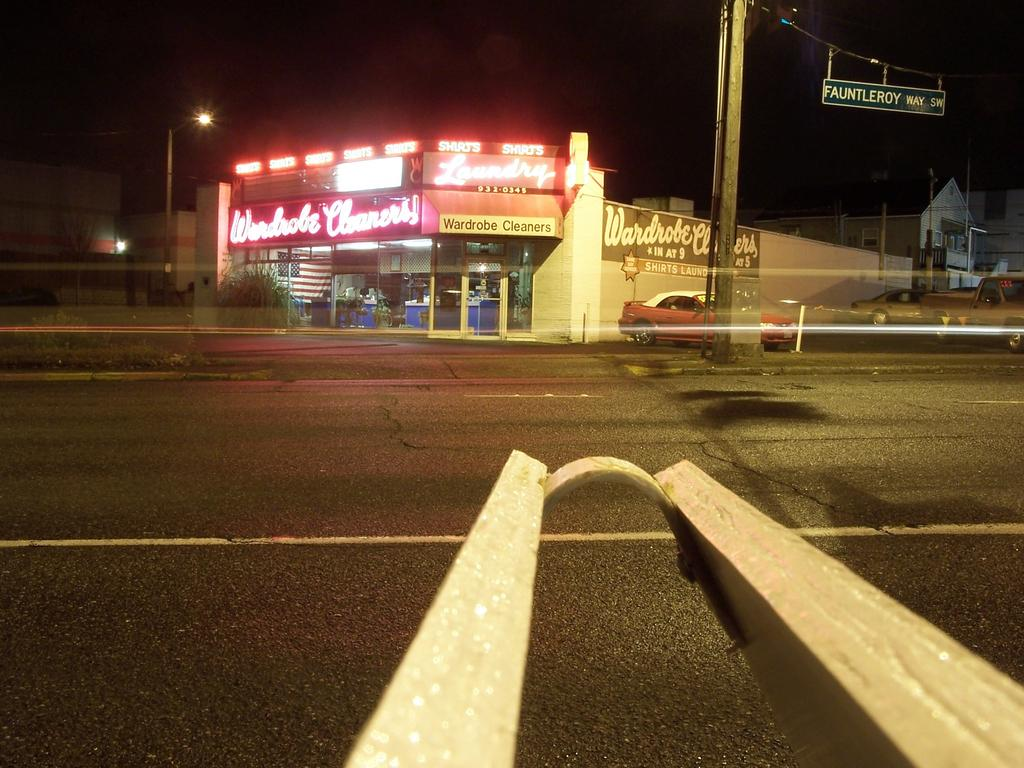What is the main feature of the image? There is a road in the image. What can be found beside the road? There is an object beside the road. What is visible in the background of the image? There is a store and vehicles in the background. What type of treatment is being administered to the yam in the image? There is no yam present in the image, so no treatment can be administered. How does the image demonstrate respect for the elderly? The image does not depict any elderly individuals or demonstrate respect for them. 